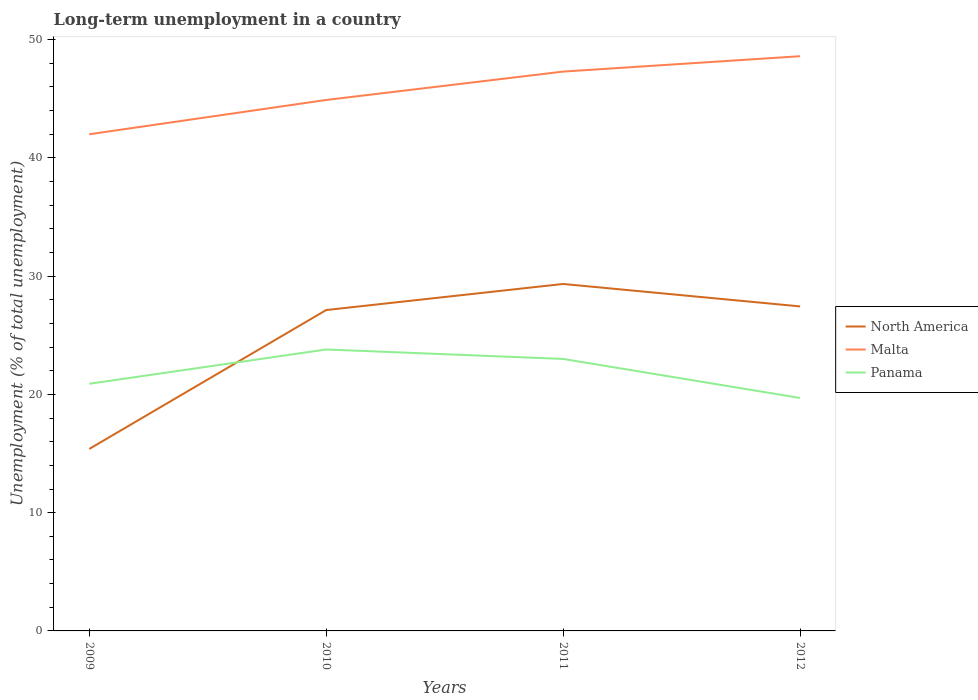How many different coloured lines are there?
Provide a succinct answer. 3. Is the number of lines equal to the number of legend labels?
Give a very brief answer. Yes. Across all years, what is the maximum percentage of long-term unemployed population in Malta?
Offer a terse response. 42. What is the total percentage of long-term unemployed population in North America in the graph?
Your answer should be very brief. -11.75. What is the difference between the highest and the second highest percentage of long-term unemployed population in North America?
Give a very brief answer. 13.95. What is the difference between the highest and the lowest percentage of long-term unemployed population in Malta?
Offer a terse response. 2. How many years are there in the graph?
Your answer should be compact. 4. Where does the legend appear in the graph?
Ensure brevity in your answer.  Center right. How are the legend labels stacked?
Provide a succinct answer. Vertical. What is the title of the graph?
Keep it short and to the point. Long-term unemployment in a country. What is the label or title of the X-axis?
Your answer should be very brief. Years. What is the label or title of the Y-axis?
Make the answer very short. Unemployment (% of total unemployment). What is the Unemployment (% of total unemployment) in North America in 2009?
Your response must be concise. 15.39. What is the Unemployment (% of total unemployment) in Malta in 2009?
Your answer should be very brief. 42. What is the Unemployment (% of total unemployment) in Panama in 2009?
Your response must be concise. 20.9. What is the Unemployment (% of total unemployment) of North America in 2010?
Ensure brevity in your answer.  27.14. What is the Unemployment (% of total unemployment) of Malta in 2010?
Keep it short and to the point. 44.9. What is the Unemployment (% of total unemployment) in Panama in 2010?
Your response must be concise. 23.8. What is the Unemployment (% of total unemployment) of North America in 2011?
Provide a succinct answer. 29.34. What is the Unemployment (% of total unemployment) of Malta in 2011?
Give a very brief answer. 47.3. What is the Unemployment (% of total unemployment) in Panama in 2011?
Ensure brevity in your answer.  23. What is the Unemployment (% of total unemployment) of North America in 2012?
Offer a very short reply. 27.44. What is the Unemployment (% of total unemployment) of Malta in 2012?
Your answer should be very brief. 48.6. What is the Unemployment (% of total unemployment) in Panama in 2012?
Make the answer very short. 19.7. Across all years, what is the maximum Unemployment (% of total unemployment) of North America?
Your answer should be very brief. 29.34. Across all years, what is the maximum Unemployment (% of total unemployment) in Malta?
Your answer should be very brief. 48.6. Across all years, what is the maximum Unemployment (% of total unemployment) of Panama?
Give a very brief answer. 23.8. Across all years, what is the minimum Unemployment (% of total unemployment) of North America?
Provide a succinct answer. 15.39. Across all years, what is the minimum Unemployment (% of total unemployment) of Malta?
Ensure brevity in your answer.  42. Across all years, what is the minimum Unemployment (% of total unemployment) of Panama?
Provide a short and direct response. 19.7. What is the total Unemployment (% of total unemployment) in North America in the graph?
Keep it short and to the point. 99.31. What is the total Unemployment (% of total unemployment) of Malta in the graph?
Your answer should be very brief. 182.8. What is the total Unemployment (% of total unemployment) in Panama in the graph?
Offer a terse response. 87.4. What is the difference between the Unemployment (% of total unemployment) in North America in 2009 and that in 2010?
Your answer should be very brief. -11.75. What is the difference between the Unemployment (% of total unemployment) in Malta in 2009 and that in 2010?
Your answer should be very brief. -2.9. What is the difference between the Unemployment (% of total unemployment) in North America in 2009 and that in 2011?
Your answer should be compact. -13.95. What is the difference between the Unemployment (% of total unemployment) of Panama in 2009 and that in 2011?
Keep it short and to the point. -2.1. What is the difference between the Unemployment (% of total unemployment) in North America in 2009 and that in 2012?
Make the answer very short. -12.05. What is the difference between the Unemployment (% of total unemployment) of Panama in 2009 and that in 2012?
Offer a terse response. 1.2. What is the difference between the Unemployment (% of total unemployment) of North America in 2010 and that in 2011?
Give a very brief answer. -2.2. What is the difference between the Unemployment (% of total unemployment) of Malta in 2010 and that in 2011?
Your response must be concise. -2.4. What is the difference between the Unemployment (% of total unemployment) of North America in 2010 and that in 2012?
Provide a succinct answer. -0.31. What is the difference between the Unemployment (% of total unemployment) in Panama in 2010 and that in 2012?
Your response must be concise. 4.1. What is the difference between the Unemployment (% of total unemployment) of North America in 2011 and that in 2012?
Your answer should be compact. 1.9. What is the difference between the Unemployment (% of total unemployment) of Panama in 2011 and that in 2012?
Provide a short and direct response. 3.3. What is the difference between the Unemployment (% of total unemployment) in North America in 2009 and the Unemployment (% of total unemployment) in Malta in 2010?
Your answer should be very brief. -29.51. What is the difference between the Unemployment (% of total unemployment) in North America in 2009 and the Unemployment (% of total unemployment) in Panama in 2010?
Your answer should be very brief. -8.41. What is the difference between the Unemployment (% of total unemployment) of North America in 2009 and the Unemployment (% of total unemployment) of Malta in 2011?
Provide a succinct answer. -31.91. What is the difference between the Unemployment (% of total unemployment) in North America in 2009 and the Unemployment (% of total unemployment) in Panama in 2011?
Make the answer very short. -7.61. What is the difference between the Unemployment (% of total unemployment) in Malta in 2009 and the Unemployment (% of total unemployment) in Panama in 2011?
Offer a very short reply. 19. What is the difference between the Unemployment (% of total unemployment) of North America in 2009 and the Unemployment (% of total unemployment) of Malta in 2012?
Offer a terse response. -33.21. What is the difference between the Unemployment (% of total unemployment) of North America in 2009 and the Unemployment (% of total unemployment) of Panama in 2012?
Ensure brevity in your answer.  -4.31. What is the difference between the Unemployment (% of total unemployment) of Malta in 2009 and the Unemployment (% of total unemployment) of Panama in 2012?
Your response must be concise. 22.3. What is the difference between the Unemployment (% of total unemployment) in North America in 2010 and the Unemployment (% of total unemployment) in Malta in 2011?
Provide a succinct answer. -20.16. What is the difference between the Unemployment (% of total unemployment) of North America in 2010 and the Unemployment (% of total unemployment) of Panama in 2011?
Offer a terse response. 4.14. What is the difference between the Unemployment (% of total unemployment) of Malta in 2010 and the Unemployment (% of total unemployment) of Panama in 2011?
Your response must be concise. 21.9. What is the difference between the Unemployment (% of total unemployment) in North America in 2010 and the Unemployment (% of total unemployment) in Malta in 2012?
Give a very brief answer. -21.46. What is the difference between the Unemployment (% of total unemployment) of North America in 2010 and the Unemployment (% of total unemployment) of Panama in 2012?
Give a very brief answer. 7.44. What is the difference between the Unemployment (% of total unemployment) in Malta in 2010 and the Unemployment (% of total unemployment) in Panama in 2012?
Offer a terse response. 25.2. What is the difference between the Unemployment (% of total unemployment) of North America in 2011 and the Unemployment (% of total unemployment) of Malta in 2012?
Keep it short and to the point. -19.26. What is the difference between the Unemployment (% of total unemployment) of North America in 2011 and the Unemployment (% of total unemployment) of Panama in 2012?
Ensure brevity in your answer.  9.64. What is the difference between the Unemployment (% of total unemployment) of Malta in 2011 and the Unemployment (% of total unemployment) of Panama in 2012?
Offer a very short reply. 27.6. What is the average Unemployment (% of total unemployment) in North America per year?
Make the answer very short. 24.83. What is the average Unemployment (% of total unemployment) of Malta per year?
Your response must be concise. 45.7. What is the average Unemployment (% of total unemployment) in Panama per year?
Keep it short and to the point. 21.85. In the year 2009, what is the difference between the Unemployment (% of total unemployment) in North America and Unemployment (% of total unemployment) in Malta?
Offer a terse response. -26.61. In the year 2009, what is the difference between the Unemployment (% of total unemployment) in North America and Unemployment (% of total unemployment) in Panama?
Your response must be concise. -5.51. In the year 2009, what is the difference between the Unemployment (% of total unemployment) of Malta and Unemployment (% of total unemployment) of Panama?
Offer a terse response. 21.1. In the year 2010, what is the difference between the Unemployment (% of total unemployment) of North America and Unemployment (% of total unemployment) of Malta?
Your response must be concise. -17.76. In the year 2010, what is the difference between the Unemployment (% of total unemployment) of North America and Unemployment (% of total unemployment) of Panama?
Provide a succinct answer. 3.34. In the year 2010, what is the difference between the Unemployment (% of total unemployment) in Malta and Unemployment (% of total unemployment) in Panama?
Ensure brevity in your answer.  21.1. In the year 2011, what is the difference between the Unemployment (% of total unemployment) of North America and Unemployment (% of total unemployment) of Malta?
Ensure brevity in your answer.  -17.96. In the year 2011, what is the difference between the Unemployment (% of total unemployment) in North America and Unemployment (% of total unemployment) in Panama?
Provide a succinct answer. 6.34. In the year 2011, what is the difference between the Unemployment (% of total unemployment) of Malta and Unemployment (% of total unemployment) of Panama?
Your answer should be very brief. 24.3. In the year 2012, what is the difference between the Unemployment (% of total unemployment) in North America and Unemployment (% of total unemployment) in Malta?
Your response must be concise. -21.16. In the year 2012, what is the difference between the Unemployment (% of total unemployment) in North America and Unemployment (% of total unemployment) in Panama?
Your answer should be compact. 7.74. In the year 2012, what is the difference between the Unemployment (% of total unemployment) of Malta and Unemployment (% of total unemployment) of Panama?
Your answer should be very brief. 28.9. What is the ratio of the Unemployment (% of total unemployment) in North America in 2009 to that in 2010?
Ensure brevity in your answer.  0.57. What is the ratio of the Unemployment (% of total unemployment) in Malta in 2009 to that in 2010?
Ensure brevity in your answer.  0.94. What is the ratio of the Unemployment (% of total unemployment) of Panama in 2009 to that in 2010?
Offer a very short reply. 0.88. What is the ratio of the Unemployment (% of total unemployment) in North America in 2009 to that in 2011?
Offer a very short reply. 0.52. What is the ratio of the Unemployment (% of total unemployment) in Malta in 2009 to that in 2011?
Keep it short and to the point. 0.89. What is the ratio of the Unemployment (% of total unemployment) in Panama in 2009 to that in 2011?
Provide a short and direct response. 0.91. What is the ratio of the Unemployment (% of total unemployment) in North America in 2009 to that in 2012?
Offer a terse response. 0.56. What is the ratio of the Unemployment (% of total unemployment) of Malta in 2009 to that in 2012?
Give a very brief answer. 0.86. What is the ratio of the Unemployment (% of total unemployment) of Panama in 2009 to that in 2012?
Keep it short and to the point. 1.06. What is the ratio of the Unemployment (% of total unemployment) of North America in 2010 to that in 2011?
Give a very brief answer. 0.92. What is the ratio of the Unemployment (% of total unemployment) in Malta in 2010 to that in 2011?
Ensure brevity in your answer.  0.95. What is the ratio of the Unemployment (% of total unemployment) in Panama in 2010 to that in 2011?
Give a very brief answer. 1.03. What is the ratio of the Unemployment (% of total unemployment) of Malta in 2010 to that in 2012?
Provide a short and direct response. 0.92. What is the ratio of the Unemployment (% of total unemployment) in Panama in 2010 to that in 2012?
Ensure brevity in your answer.  1.21. What is the ratio of the Unemployment (% of total unemployment) of North America in 2011 to that in 2012?
Give a very brief answer. 1.07. What is the ratio of the Unemployment (% of total unemployment) of Malta in 2011 to that in 2012?
Your answer should be compact. 0.97. What is the ratio of the Unemployment (% of total unemployment) in Panama in 2011 to that in 2012?
Provide a short and direct response. 1.17. What is the difference between the highest and the second highest Unemployment (% of total unemployment) of North America?
Offer a terse response. 1.9. What is the difference between the highest and the lowest Unemployment (% of total unemployment) of North America?
Your response must be concise. 13.95. 